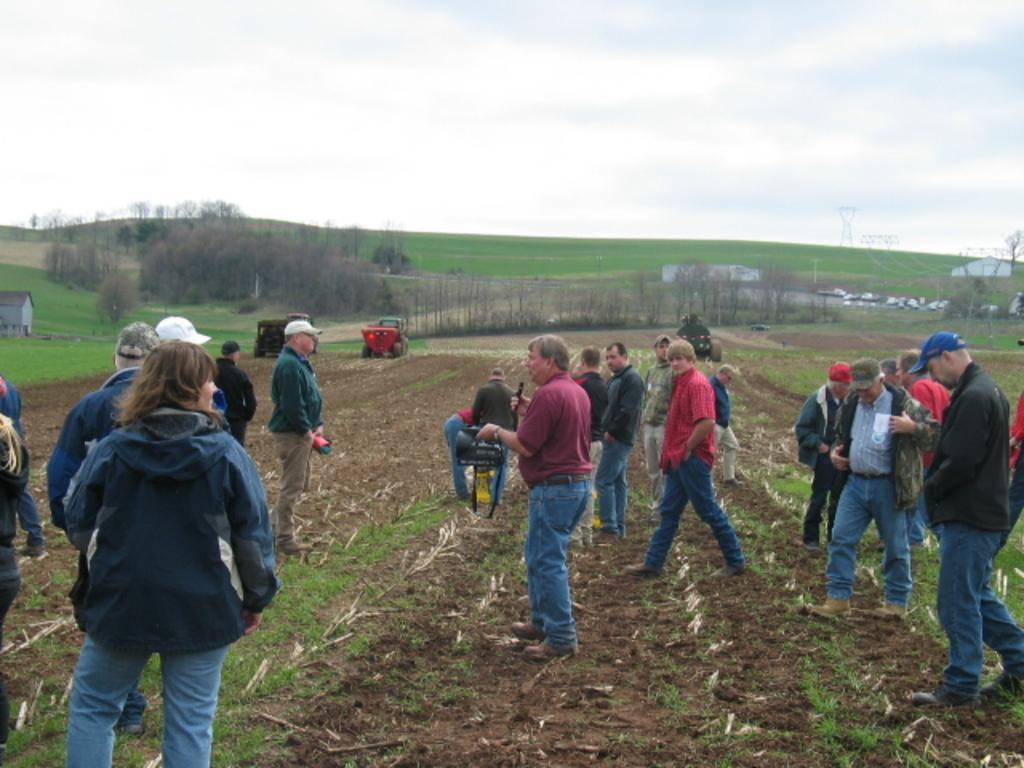Could you give a brief overview of what you see in this image? In the center of the image we can see some persons are standing and some of them are wearing jackets, hat. In the background of the image we can see the trees, grass, houses, some vehicles, ground. At the top of the image we can see the clouds are present in the sky. At the bottom of the image we can see the ground. 